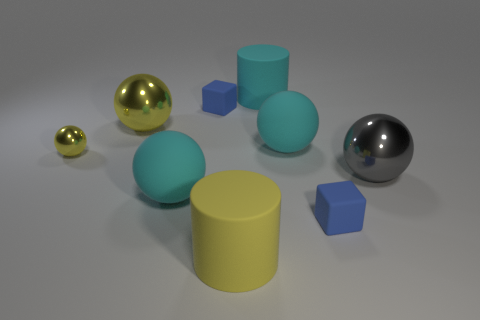How big is the metal ball that is in front of the small yellow shiny thing?
Keep it short and to the point. Large. How many objects are blue cubes that are in front of the small yellow shiny sphere or big yellow objects that are behind the big gray shiny thing?
Your answer should be compact. 2. Are there any other things that are the same color as the small ball?
Your answer should be compact. Yes. Is the number of metallic things on the right side of the tiny yellow metallic thing the same as the number of blue rubber things that are behind the large yellow rubber cylinder?
Ensure brevity in your answer.  Yes. Are there more matte blocks in front of the big yellow shiny thing than small red objects?
Your answer should be very brief. Yes. What number of things are either small matte cubes in front of the large yellow metallic object or metal objects?
Ensure brevity in your answer.  4. How many other big things are made of the same material as the big gray object?
Make the answer very short. 1. What is the shape of the metallic object that is the same color as the tiny shiny sphere?
Provide a succinct answer. Sphere. Is there another large shiny thing of the same shape as the big gray metallic thing?
Ensure brevity in your answer.  Yes. The yellow matte thing that is the same size as the cyan matte cylinder is what shape?
Make the answer very short. Cylinder. 